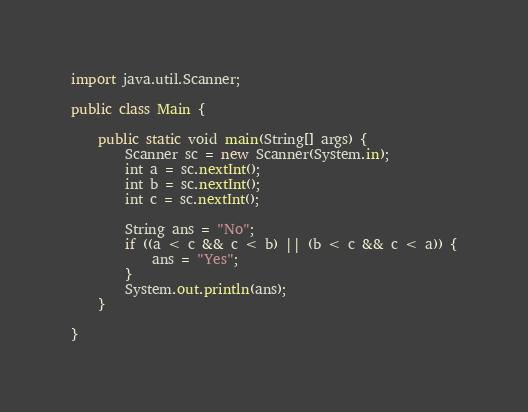<code> <loc_0><loc_0><loc_500><loc_500><_Java_>import java.util.Scanner;

public class Main {

	public static void main(String[] args) {
		Scanner sc = new Scanner(System.in);
		int a = sc.nextInt();
		int b = sc.nextInt();
		int c = sc.nextInt();

		String ans = "No";
		if ((a < c && c < b) || (b < c && c < a)) {
			ans = "Yes";
		}
		System.out.println(ans);
	}

}
</code> 